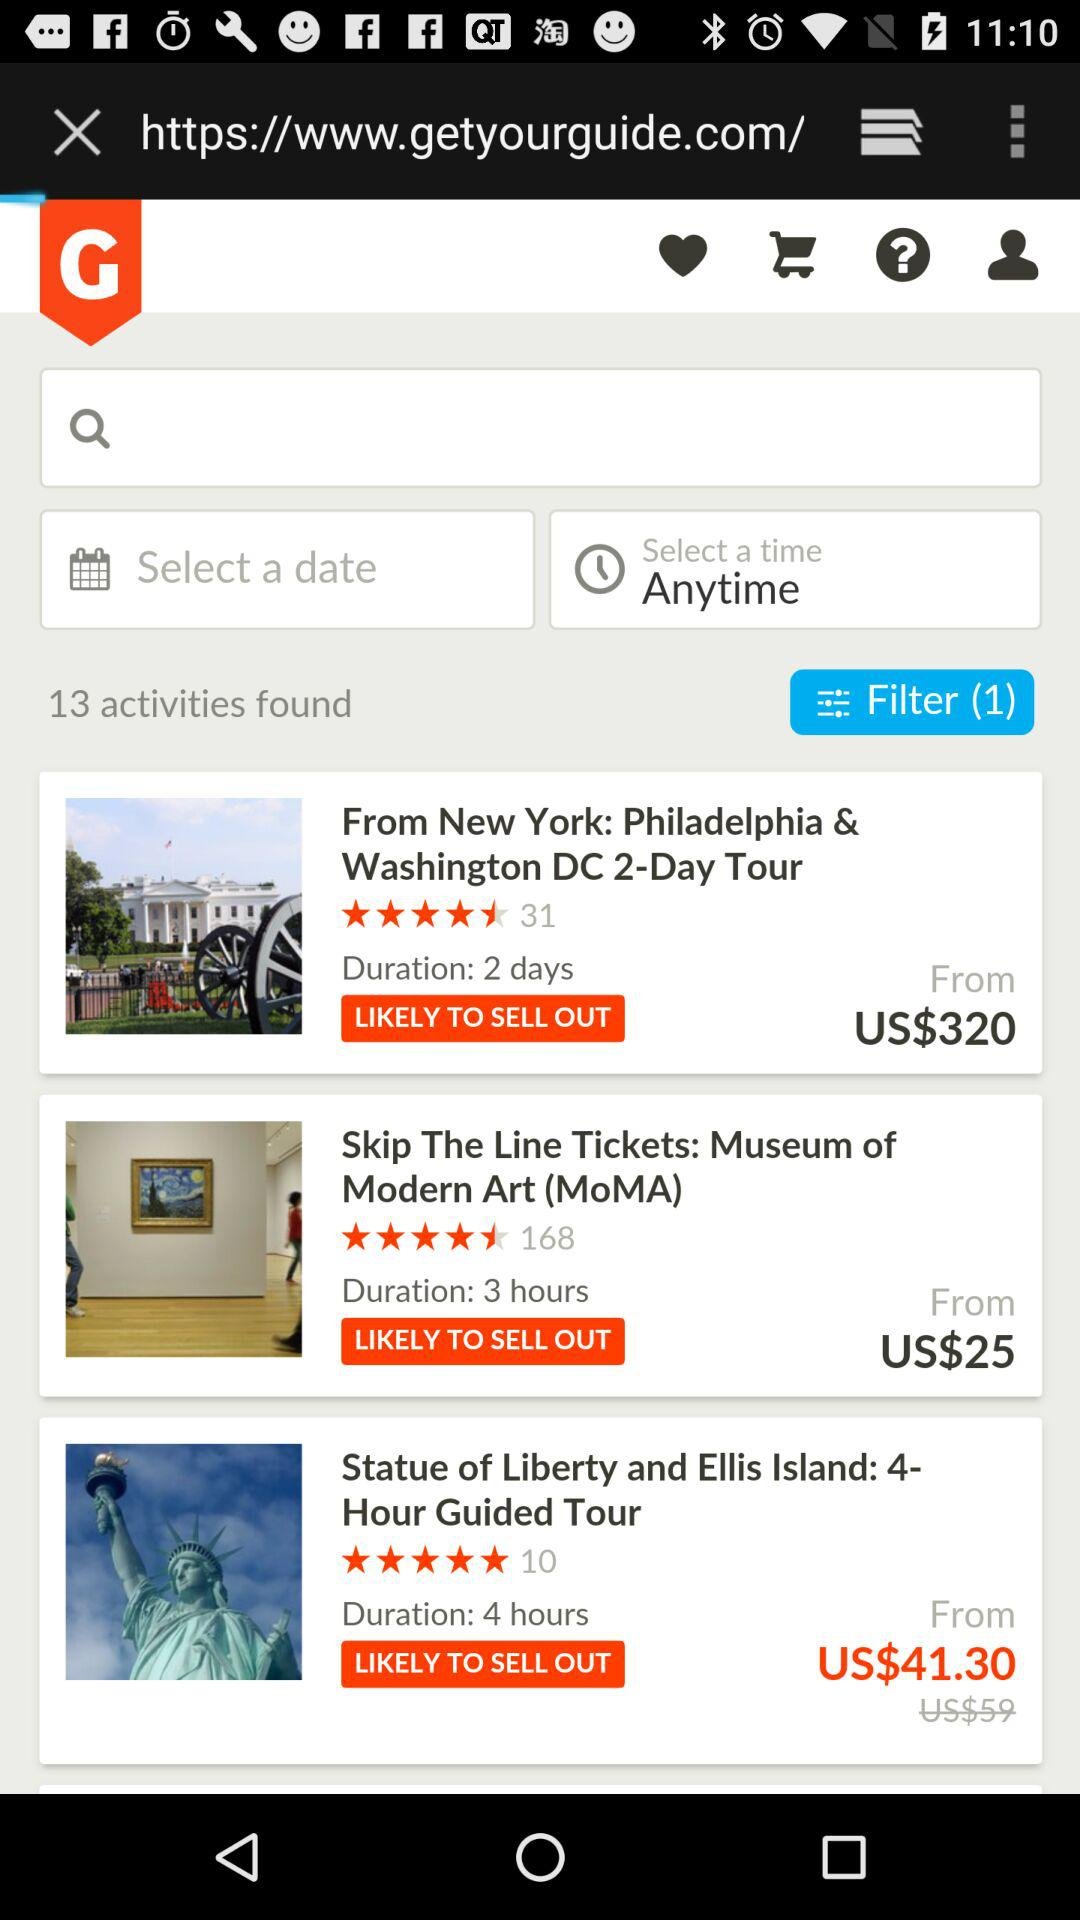How many items are in the filter option? There is 1 item. 